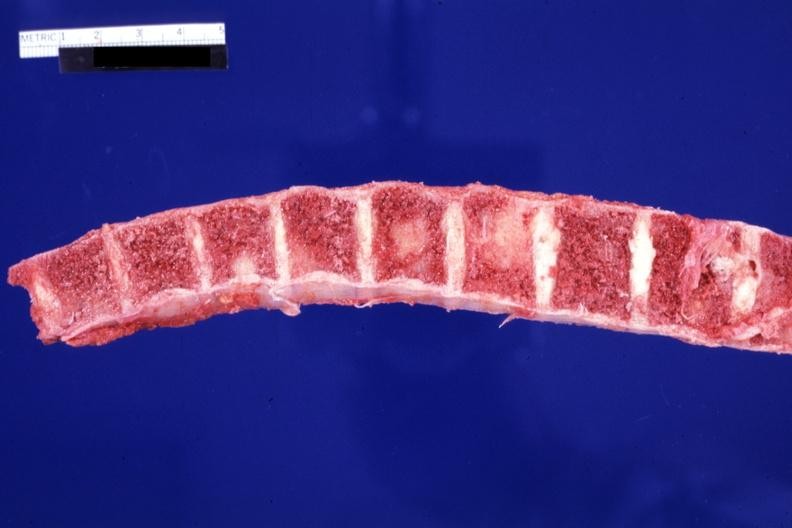what is present?
Answer the question using a single word or phrase. Joints 